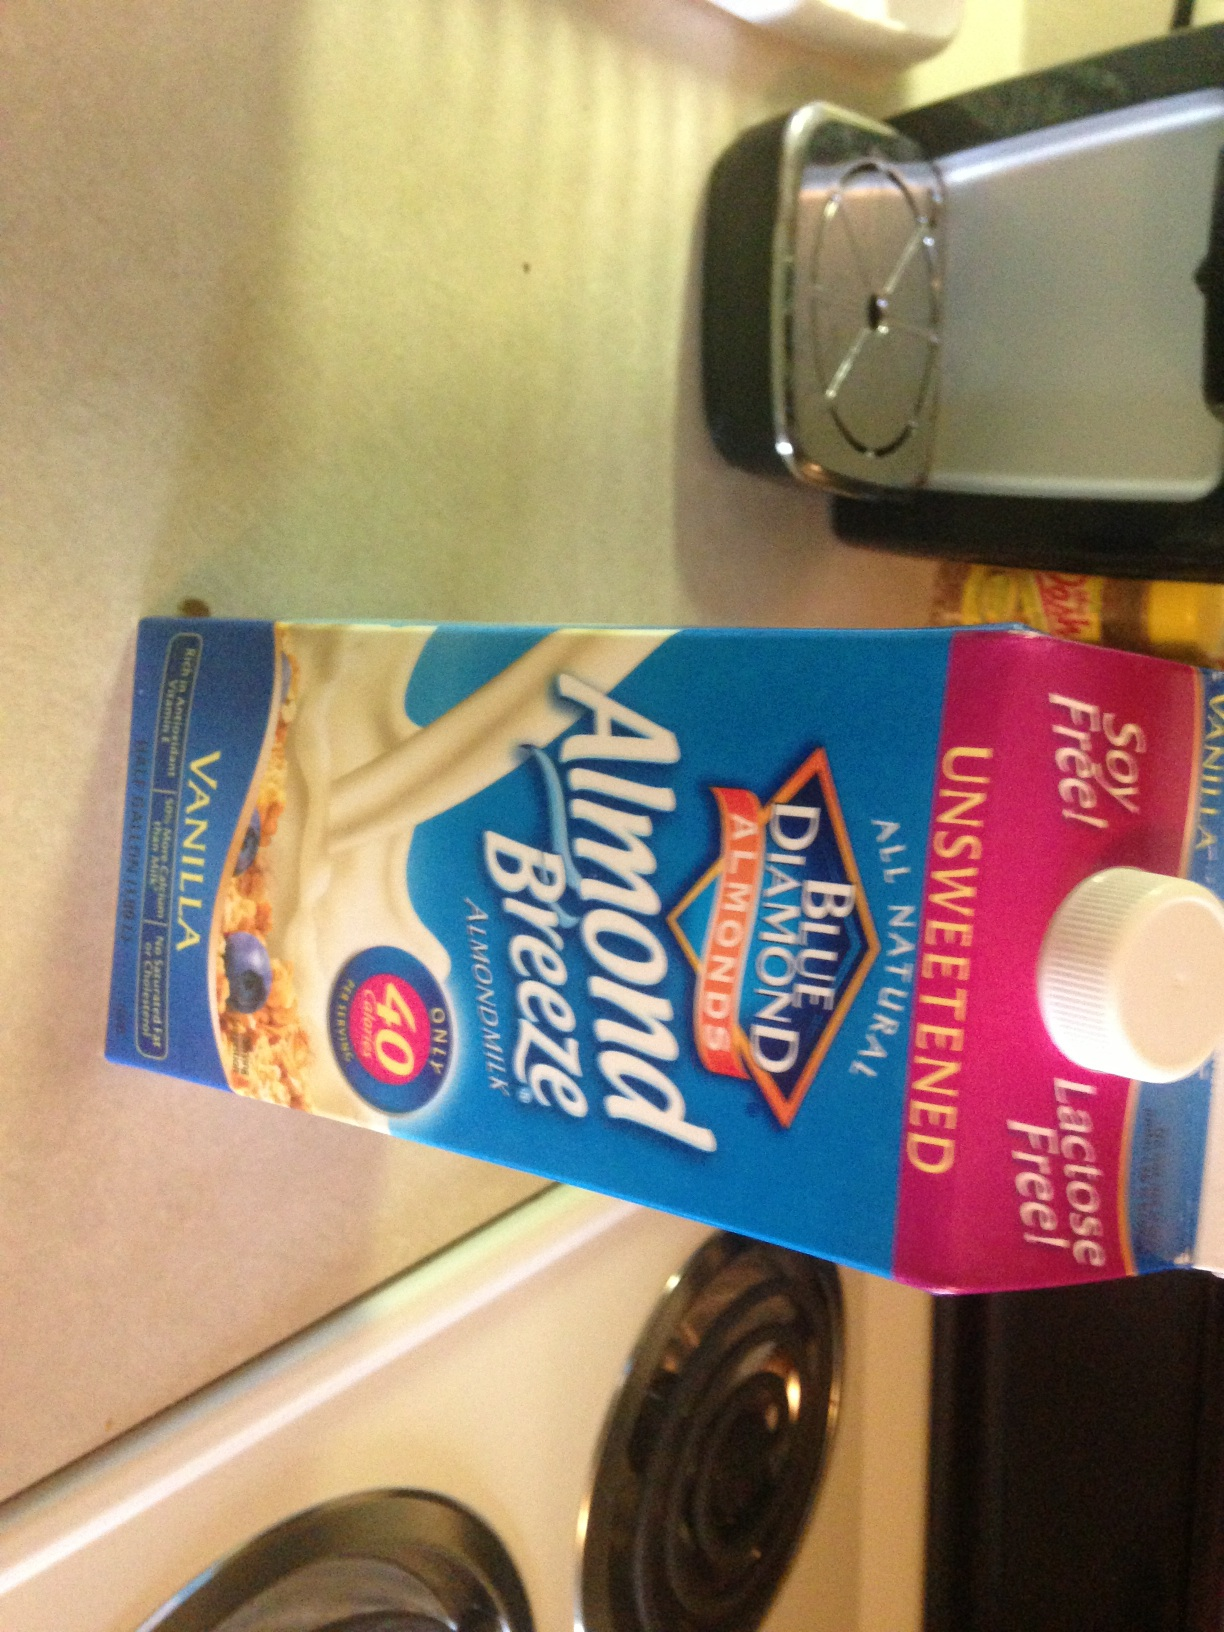How is unsweetened almond milk used in cooking? Unsweetened almond milk is versatile in cooking and baking. It can substitute for dairy milk in recipes like smoothies, pancakes, and sauces to reduce calorie intake and eliminate lactose. Its mild flavor and creamy texture make it ideal for both sweet and savory dishes. 